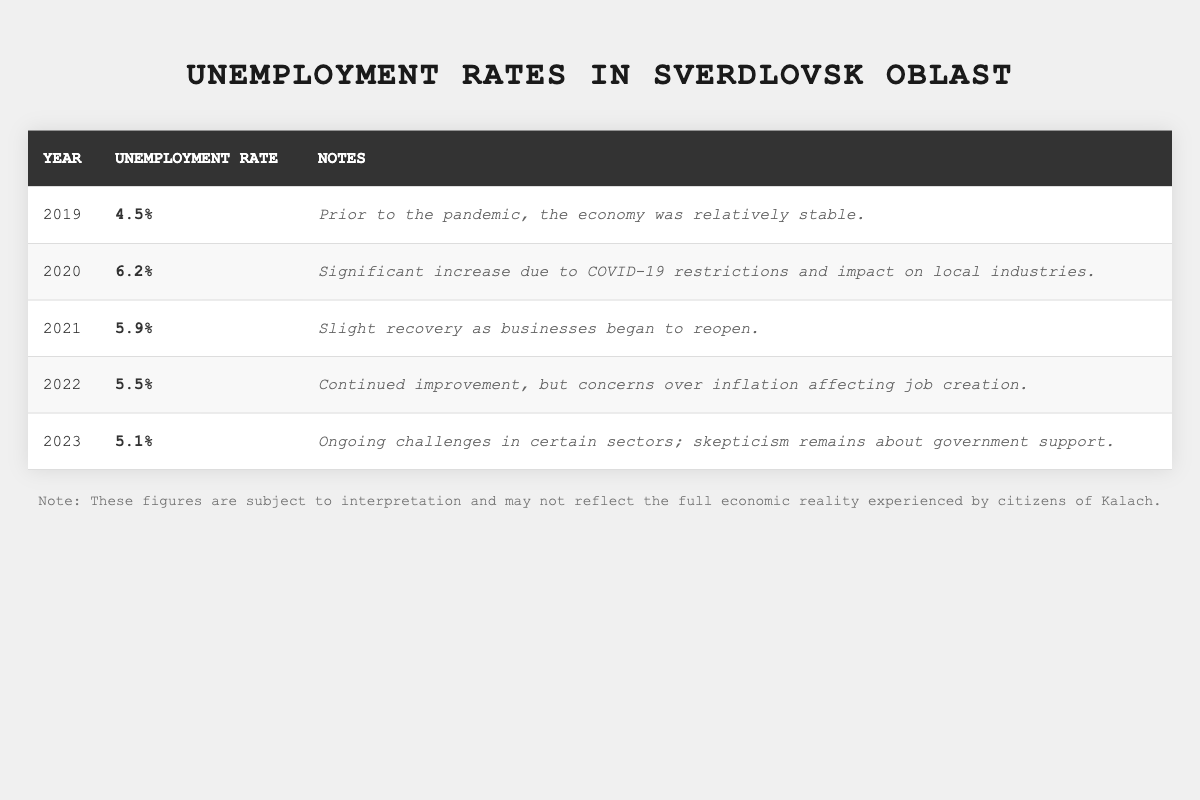What was the unemployment rate in 2019? The table shows the unemployment rate for each year. For 2019, the unemployment rate listed is 4.5%.
Answer: 4.5% Which year saw the highest unemployment rate? By examining the rates in the table, 2020 shows the highest unemployment rate at 6.2%.
Answer: 2020 What is the change in unemployment rate from 2022 to 2023? The unemployment rate in 2022 was 5.5% and in 2023 it was 5.1%. The change is calculated as 5.5% - 5.1% = 0.4%.
Answer: 0.4% Did the unemployment rate decrease every year after 2020? In reviewing the table, the unemployment rate decreased from 2020 (6.2%) to 2021 (5.9%) and further to 2022 (5.5%), but then decreased again to 2023 (5.1%). Therefore, it did decrease every year after 2020.
Answer: Yes What was the average unemployment rate over the five years? The rates for the five years are 4.5%, 6.2%, 5.9%, 5.5%, and 5.1%. To find the average, sum these rates: (4.5 + 6.2 + 5.9 + 5.5 + 5.1) = 27.2. Then divide by 5, which gives 27.2 / 5 = 5.44%.
Answer: 5.44% In what year did unemployment fall below 6% for the first time after 2020? Starting from 2020's rate of 6.2%, the unemployment rates for 2021 and 2022 show a decrease. It falls below 6% in 2022 (5.5%).
Answer: 2022 How many years had an unemployment rate above 5%? Analyzing the table, the years 2019 (4.5%), 2020 (6.2%), 2021 (5.9%), 2022 (5.5%), and 2023 (5.1%) indicate that four years had rates above 5% (2020, 2021, 2022, and 2023).
Answer: Four What percentage did the unemployment rate decrease from 2020 to 2023? The rate in 2020 was 6.2% and in 2023 it was 5.1%. The decrease can be calculated as 6.2% - 5.1% = 1.1%. To find percentage decrease, use (1.1 / 6.2) * 100 = 17.74%.
Answer: 17.74% Which year experienced a slight recovery and what was the unemployment rate for that year? The table notes that 2021 experienced a slight recovery, with the unemployment rate recorded at 5.9%.
Answer: 5.9% 